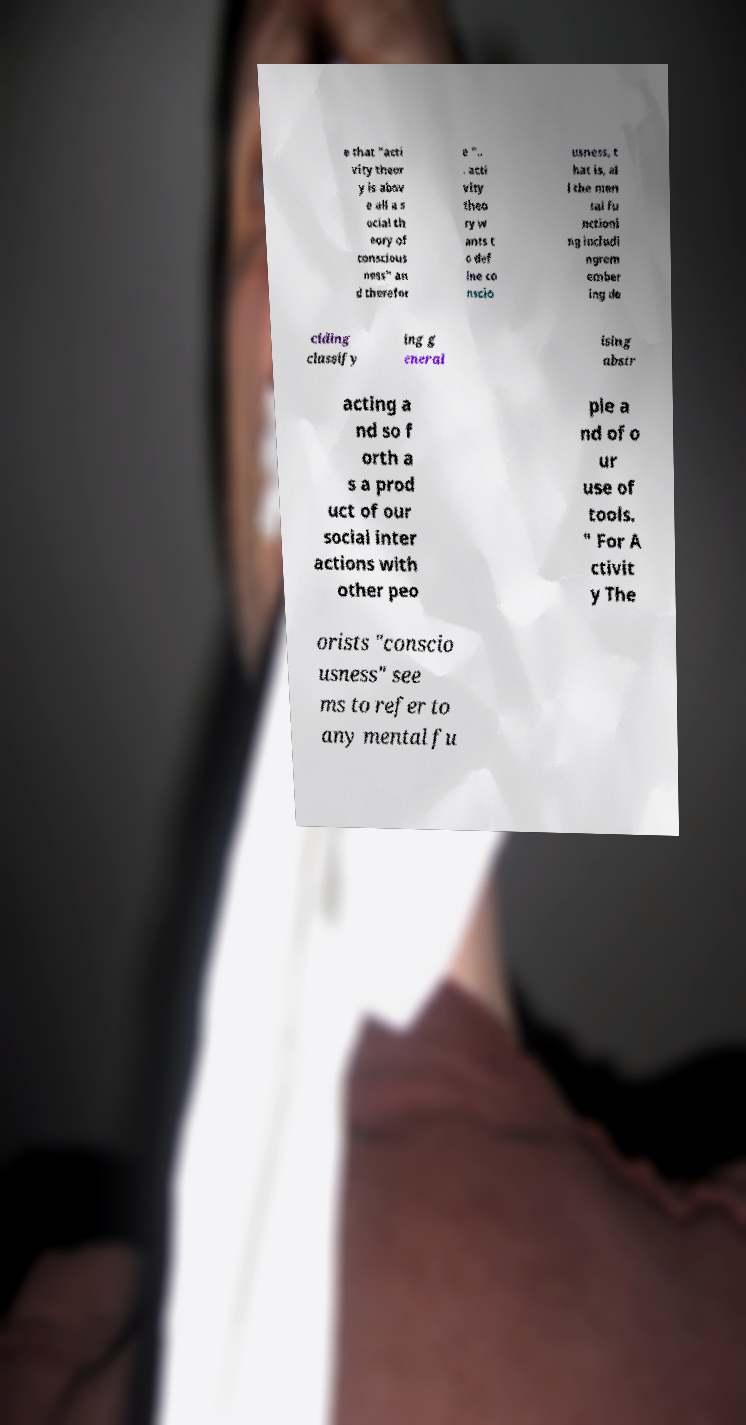What messages or text are displayed in this image? I need them in a readable, typed format. e that "acti vity theor y is abov e all a s ocial th eory of conscious ness" an d therefor e ".. . acti vity theo ry w ants t o def ine co nscio usness, t hat is, al l the men tal fu nctioni ng includi ngrem ember ing de ciding classify ing g eneral ising abstr acting a nd so f orth a s a prod uct of our social inter actions with other peo ple a nd of o ur use of tools. " For A ctivit y The orists "conscio usness" see ms to refer to any mental fu 